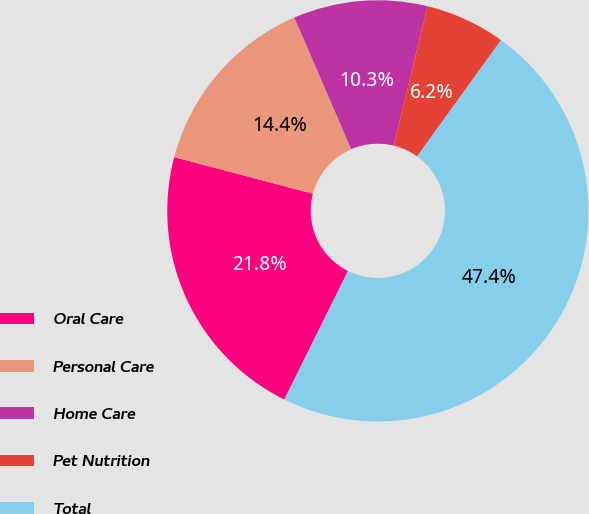<chart> <loc_0><loc_0><loc_500><loc_500><pie_chart><fcel>Oral Care<fcel>Personal Care<fcel>Home Care<fcel>Pet Nutrition<fcel>Total<nl><fcel>21.79%<fcel>14.4%<fcel>10.28%<fcel>6.16%<fcel>47.37%<nl></chart> 